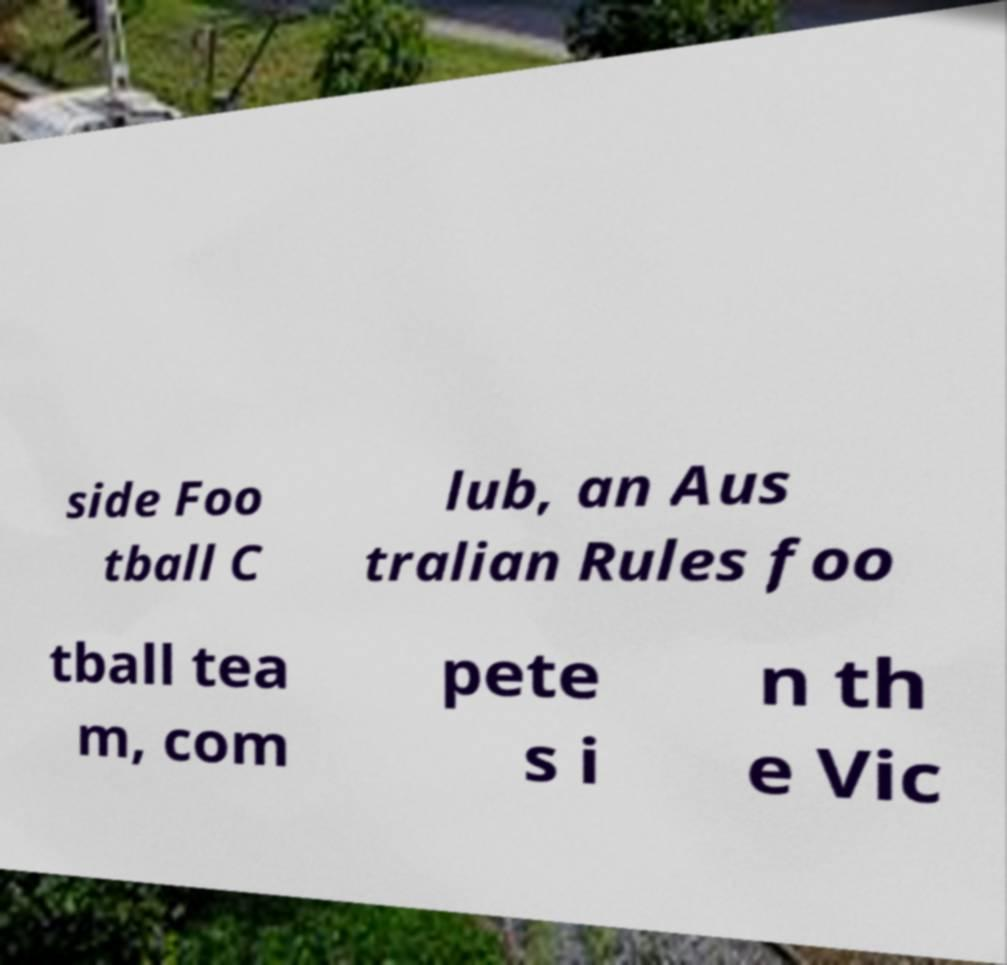Please read and relay the text visible in this image. What does it say? side Foo tball C lub, an Aus tralian Rules foo tball tea m, com pete s i n th e Vic 